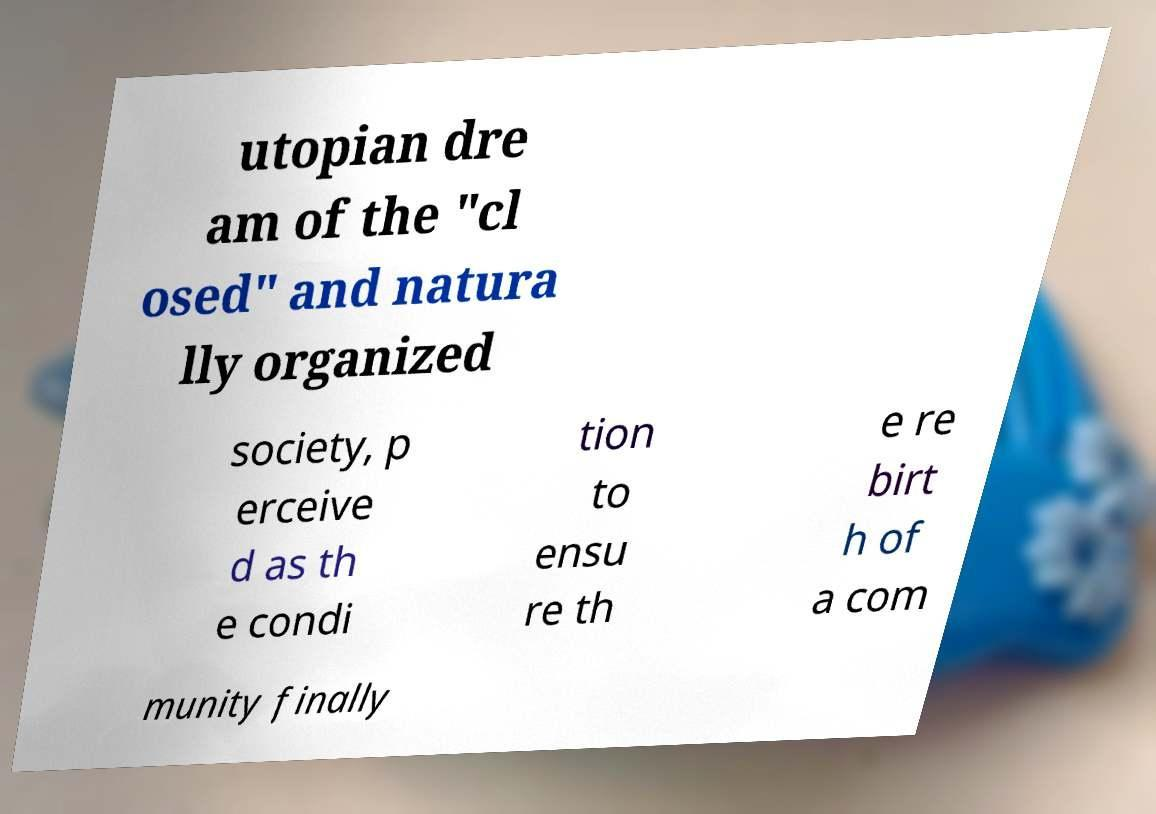Can you accurately transcribe the text from the provided image for me? utopian dre am of the "cl osed" and natura lly organized society, p erceive d as th e condi tion to ensu re th e re birt h of a com munity finally 